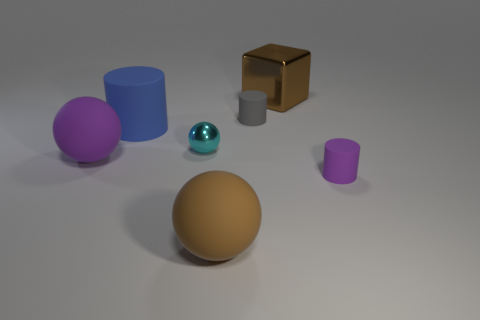Are there any other things that are the same shape as the big metal thing?
Provide a succinct answer. No. How many cylinders are either brown objects or small purple rubber objects?
Your answer should be very brief. 1. What number of cyan metallic spheres are there?
Your response must be concise. 1. What is the size of the rubber cylinder in front of the sphere to the left of the large cylinder?
Offer a very short reply. Small. How many other things are the same size as the brown block?
Your response must be concise. 3. How many big cylinders are in front of the brown ball?
Keep it short and to the point. 0. What is the size of the gray matte thing?
Make the answer very short. Small. Do the large brown thing that is in front of the metallic sphere and the tiny gray thing right of the cyan thing have the same material?
Provide a short and direct response. Yes. Are there any big objects of the same color as the big metallic cube?
Offer a terse response. Yes. What color is the other cylinder that is the same size as the gray cylinder?
Keep it short and to the point. Purple. 